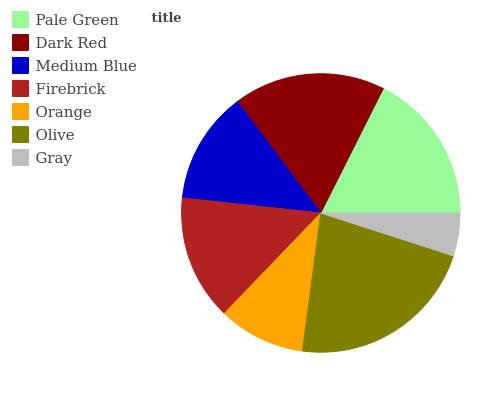Is Gray the minimum?
Answer yes or no. Yes. Is Olive the maximum?
Answer yes or no. Yes. Is Dark Red the minimum?
Answer yes or no. No. Is Dark Red the maximum?
Answer yes or no. No. Is Dark Red greater than Pale Green?
Answer yes or no. Yes. Is Pale Green less than Dark Red?
Answer yes or no. Yes. Is Pale Green greater than Dark Red?
Answer yes or no. No. Is Dark Red less than Pale Green?
Answer yes or no. No. Is Firebrick the high median?
Answer yes or no. Yes. Is Firebrick the low median?
Answer yes or no. Yes. Is Gray the high median?
Answer yes or no. No. Is Orange the low median?
Answer yes or no. No. 